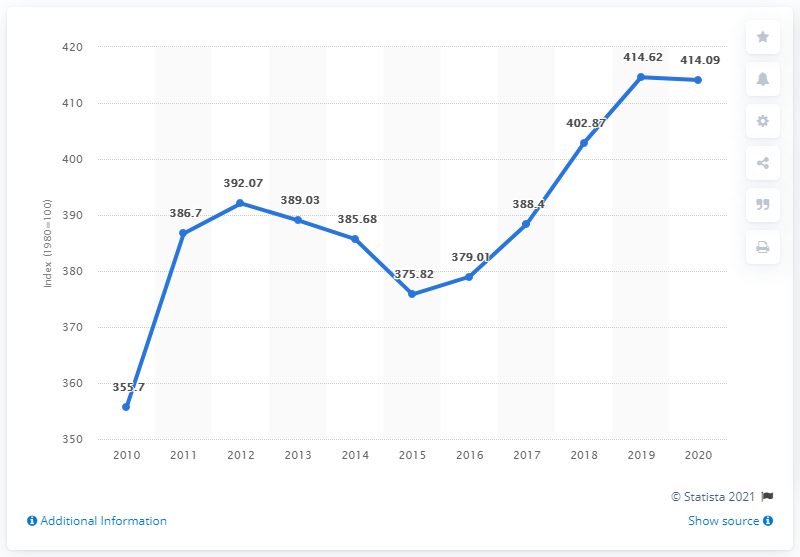List a handful of essential elements in this visual. In 2020, the consumer price index for housing, water, electricity, gas, and other fuels in Sweden was 414.09. The first data point that exceeds 400 is 414.62. The largest decrease in the Consumer Price Index (CPI) in one year is 9.86%. 